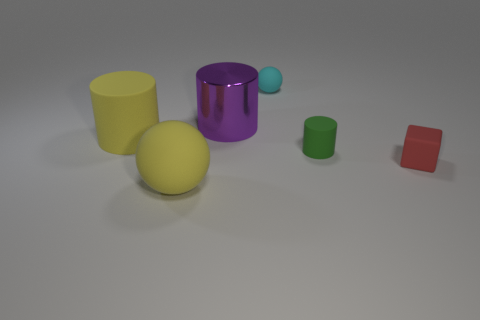The cylinder that is on the left side of the small green rubber cylinder and to the right of the large matte sphere is made of what material?
Give a very brief answer. Metal. Do the tiny green rubber object and the purple object have the same shape?
Give a very brief answer. Yes. There is a rubber ball on the right side of the metallic cylinder; does it have the same size as the small green rubber cylinder?
Offer a terse response. Yes. There is a small thing that is the same shape as the large purple metallic thing; what is its color?
Keep it short and to the point. Green. Is the sphere behind the matte block made of the same material as the big yellow cylinder?
Your response must be concise. Yes. What number of cylinders are green things or large blue matte things?
Offer a terse response. 1. What shape is the tiny thing that is in front of the small cyan thing and to the left of the red rubber block?
Offer a terse response. Cylinder. There is a matte ball that is on the right side of the big purple thing that is right of the big yellow matte object in front of the cube; what color is it?
Offer a very short reply. Cyan. Are there fewer tiny cubes in front of the large yellow rubber cylinder than big metallic objects?
Provide a short and direct response. No. Do the small red object that is in front of the tiny cyan rubber object and the tiny thing behind the small green rubber object have the same shape?
Offer a terse response. No. 